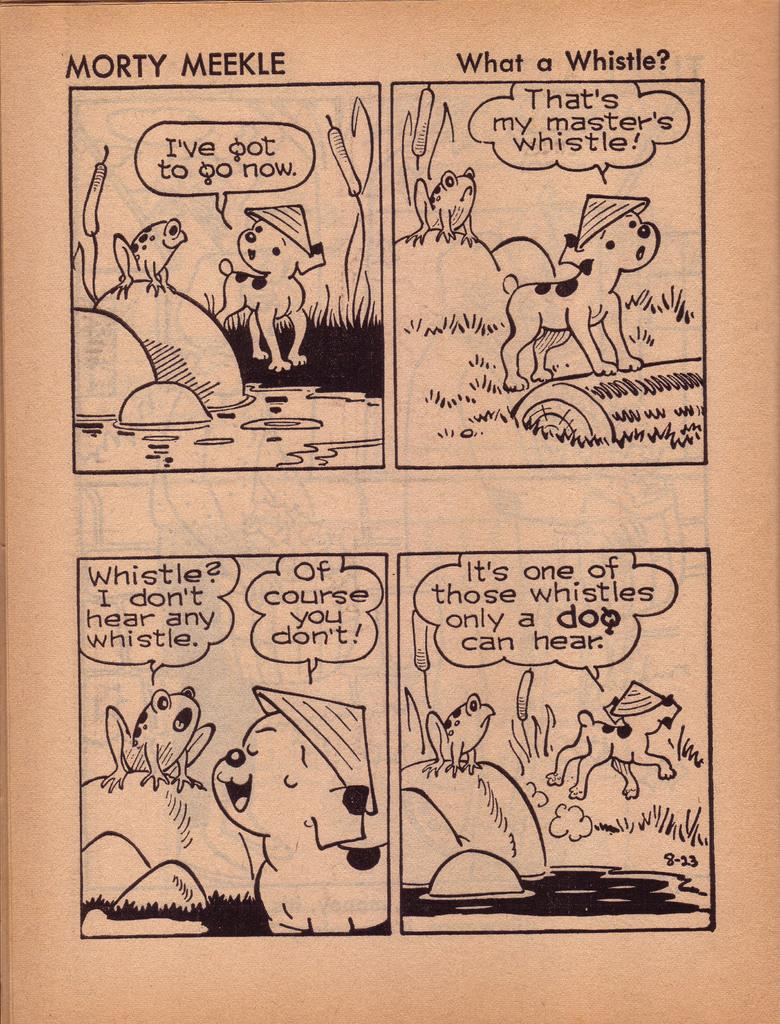<image>
Offer a succinct explanation of the picture presented. a comic by morty meekle that says what a whistle 